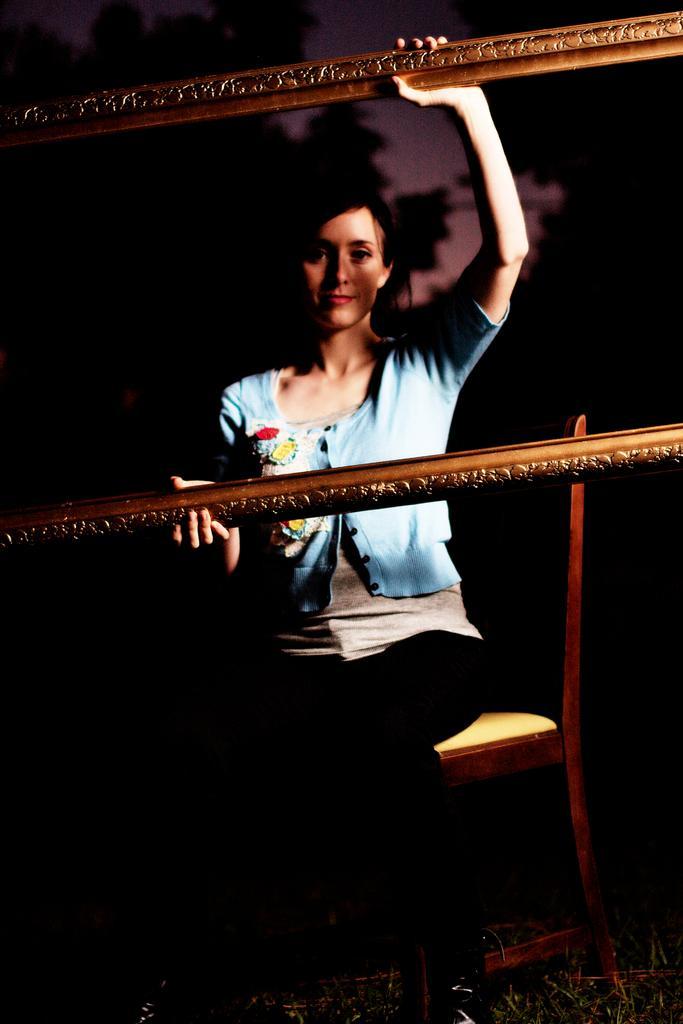Describe this image in one or two sentences. In this picture, there is a woman sitting on the chair and she is holding a empty frame and the background is dark. 